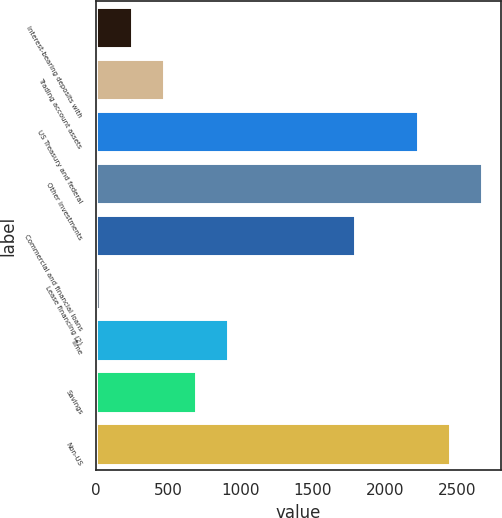Convert chart. <chart><loc_0><loc_0><loc_500><loc_500><bar_chart><fcel>Interest-bearing deposits with<fcel>Trading account assets<fcel>US Treasury and federal<fcel>Other investments<fcel>Commercial and financial loans<fcel>Lease financing (2)<fcel>Time<fcel>Savings<fcel>Non-US<nl><fcel>249.9<fcel>469.8<fcel>2229<fcel>2668.8<fcel>1789.2<fcel>30<fcel>909.6<fcel>689.7<fcel>2448.9<nl></chart> 